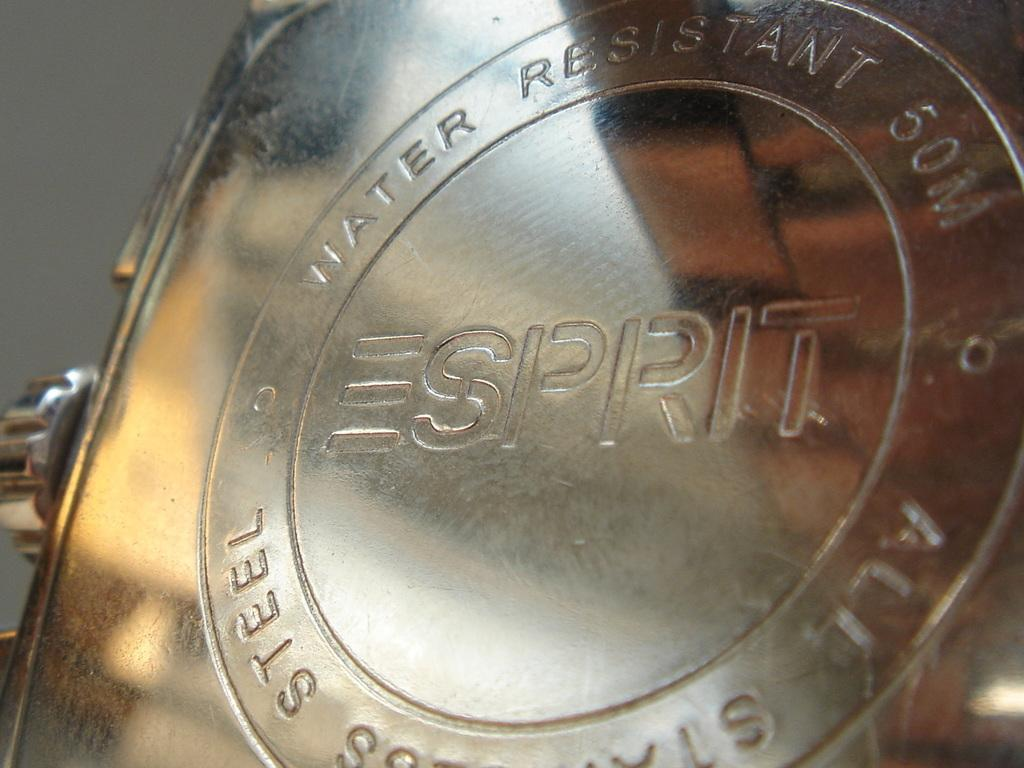<image>
Relay a brief, clear account of the picture shown. A silver object is water resistant and has the name brand Esprit on it. 